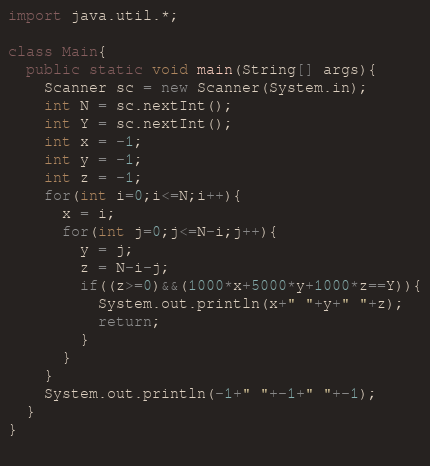Convert code to text. <code><loc_0><loc_0><loc_500><loc_500><_Java_>import java.util.*;

class Main{
  public static void main(String[] args){
    Scanner sc = new Scanner(System.in);
    int N = sc.nextInt();
    int Y = sc.nextInt();
    int x = -1;
    int y = -1;
    int z = -1;
    for(int i=0;i<=N;i++){
      x = i;
      for(int j=0;j<=N-i;j++){
        y = j;
        z = N-i-j;
        if((z>=0)&&(1000*x+5000*y+1000*z==Y)){
          System.out.println(x+" "+y+" "+z);
          return;
        }
      }
    }
    System.out.println(-1+" "+-1+" "+-1);
  }
}
    
</code> 